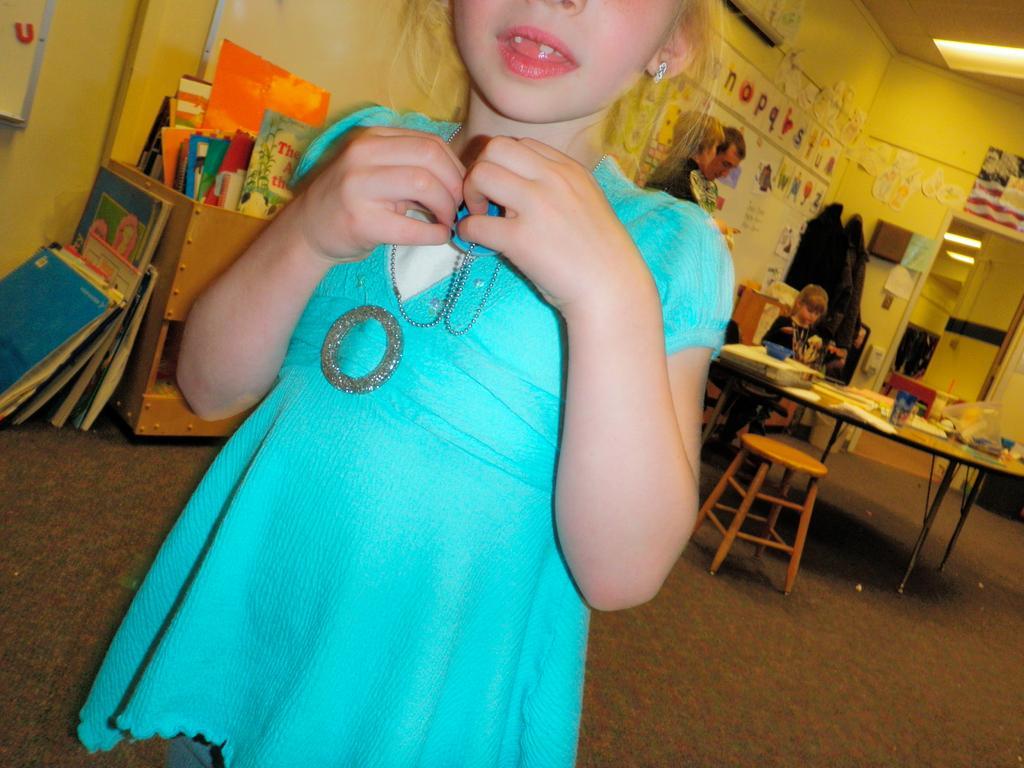Please provide a concise description of this image. This picture shows a girl standing and we see two people standing on the back and a girl seated on the chair and we see few papers on the table and we see a bookshelf 